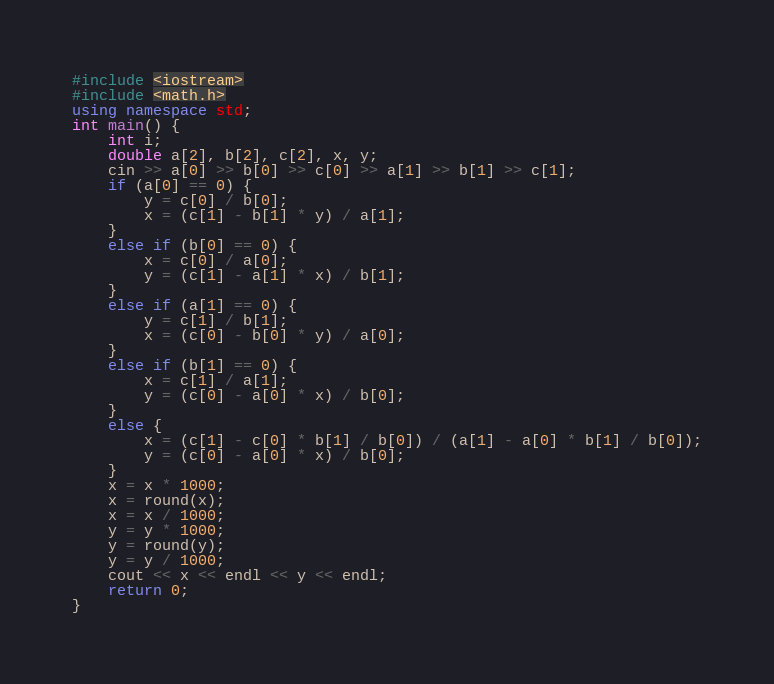Convert code to text. <code><loc_0><loc_0><loc_500><loc_500><_C++_>#include <iostream>
#include <math.h>
using namespace std;
int main() {
	int i;
	double a[2], b[2], c[2], x, y;
	cin >> a[0] >> b[0] >> c[0] >> a[1] >> b[1] >> c[1];
	if (a[0] == 0) {
		y = c[0] / b[0];
		x = (c[1] - b[1] * y) / a[1];
	}
	else if (b[0] == 0) {
		x = c[0] / a[0];
		y = (c[1] - a[1] * x) / b[1];
	}
	else if (a[1] == 0) {
		y = c[1] / b[1];
		x = (c[0] - b[0] * y) / a[0];
	}
	else if (b[1] == 0) {
		x = c[1] / a[1];
		y = (c[0] - a[0] * x) / b[0];
	}
	else {
		x = (c[1] - c[0] * b[1] / b[0]) / (a[1] - a[0] * b[1] / b[0]);
		y = (c[0] - a[0] * x) / b[0];
	}
	x = x * 1000;
	x = round(x);
	x = x / 1000;
	y = y * 1000;
	y = round(y);
	y = y / 1000;
	cout << x << endl << y << endl;
	return 0;
}</code> 